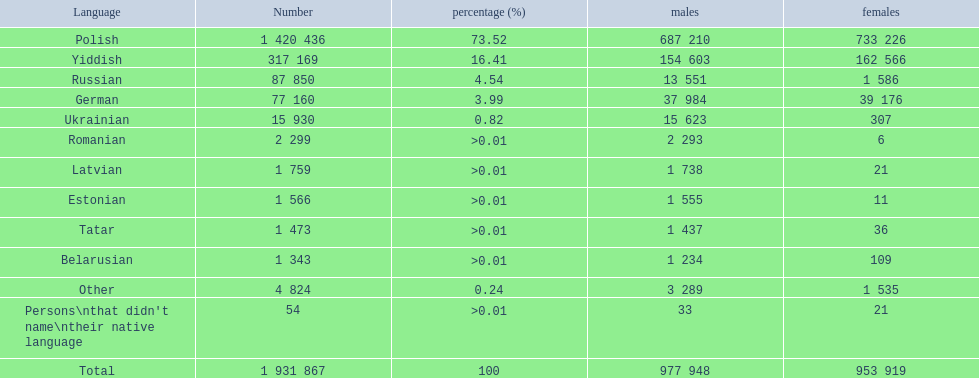What languages are spoken in the warsaw governorate? Polish, Yiddish, Russian, German, Ukrainian, Romanian, Latvian, Estonian, Tatar, Belarusian, Other, Persons\nthat didn't name\ntheir native language. What is the number for russian? 87 850. On this list what is the next lowest number? 77 160. Which language has a number of 77160 speakers? German. 